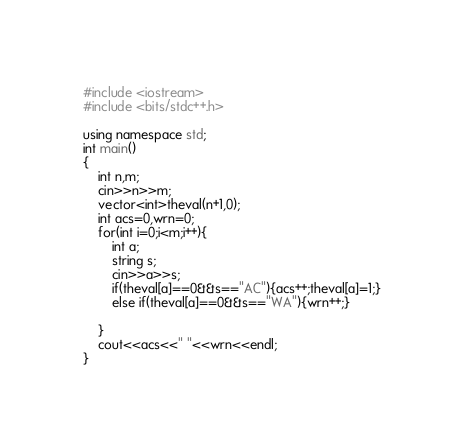<code> <loc_0><loc_0><loc_500><loc_500><_C++_>#include <iostream>
#include <bits/stdc++.h>

using namespace std;
int main()
{
    int n,m;
    cin>>n>>m;
    vector<int>theval(n+1,0);
    int acs=0,wrn=0;
    for(int i=0;i<m;i++){
        int a;
        string s;
        cin>>a>>s;
        if(theval[a]==0&&s=="AC"){acs++;theval[a]=1;}
        else if(theval[a]==0&&s=="WA"){wrn++;}
        
    }
    cout<<acs<<" "<<wrn<<endl;
}
</code> 